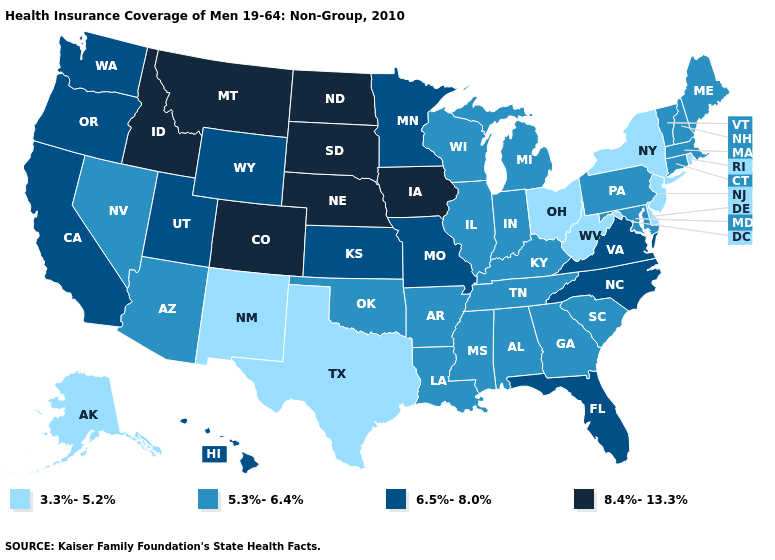Which states have the lowest value in the USA?
Be succinct. Alaska, Delaware, New Jersey, New Mexico, New York, Ohio, Rhode Island, Texas, West Virginia. Name the states that have a value in the range 8.4%-13.3%?
Keep it brief. Colorado, Idaho, Iowa, Montana, Nebraska, North Dakota, South Dakota. What is the value of Kentucky?
Concise answer only. 5.3%-6.4%. Name the states that have a value in the range 3.3%-5.2%?
Write a very short answer. Alaska, Delaware, New Jersey, New Mexico, New York, Ohio, Rhode Island, Texas, West Virginia. Does Nevada have the lowest value in the West?
Give a very brief answer. No. Does Vermont have the highest value in the USA?
Keep it brief. No. Name the states that have a value in the range 3.3%-5.2%?
Be succinct. Alaska, Delaware, New Jersey, New Mexico, New York, Ohio, Rhode Island, Texas, West Virginia. Is the legend a continuous bar?
Answer briefly. No. Name the states that have a value in the range 8.4%-13.3%?
Be succinct. Colorado, Idaho, Iowa, Montana, Nebraska, North Dakota, South Dakota. What is the value of Louisiana?
Write a very short answer. 5.3%-6.4%. Name the states that have a value in the range 8.4%-13.3%?
Concise answer only. Colorado, Idaho, Iowa, Montana, Nebraska, North Dakota, South Dakota. Name the states that have a value in the range 5.3%-6.4%?
Write a very short answer. Alabama, Arizona, Arkansas, Connecticut, Georgia, Illinois, Indiana, Kentucky, Louisiana, Maine, Maryland, Massachusetts, Michigan, Mississippi, Nevada, New Hampshire, Oklahoma, Pennsylvania, South Carolina, Tennessee, Vermont, Wisconsin. What is the value of North Carolina?
Answer briefly. 6.5%-8.0%. Does Vermont have the lowest value in the Northeast?
Answer briefly. No. What is the value of Wisconsin?
Be succinct. 5.3%-6.4%. 